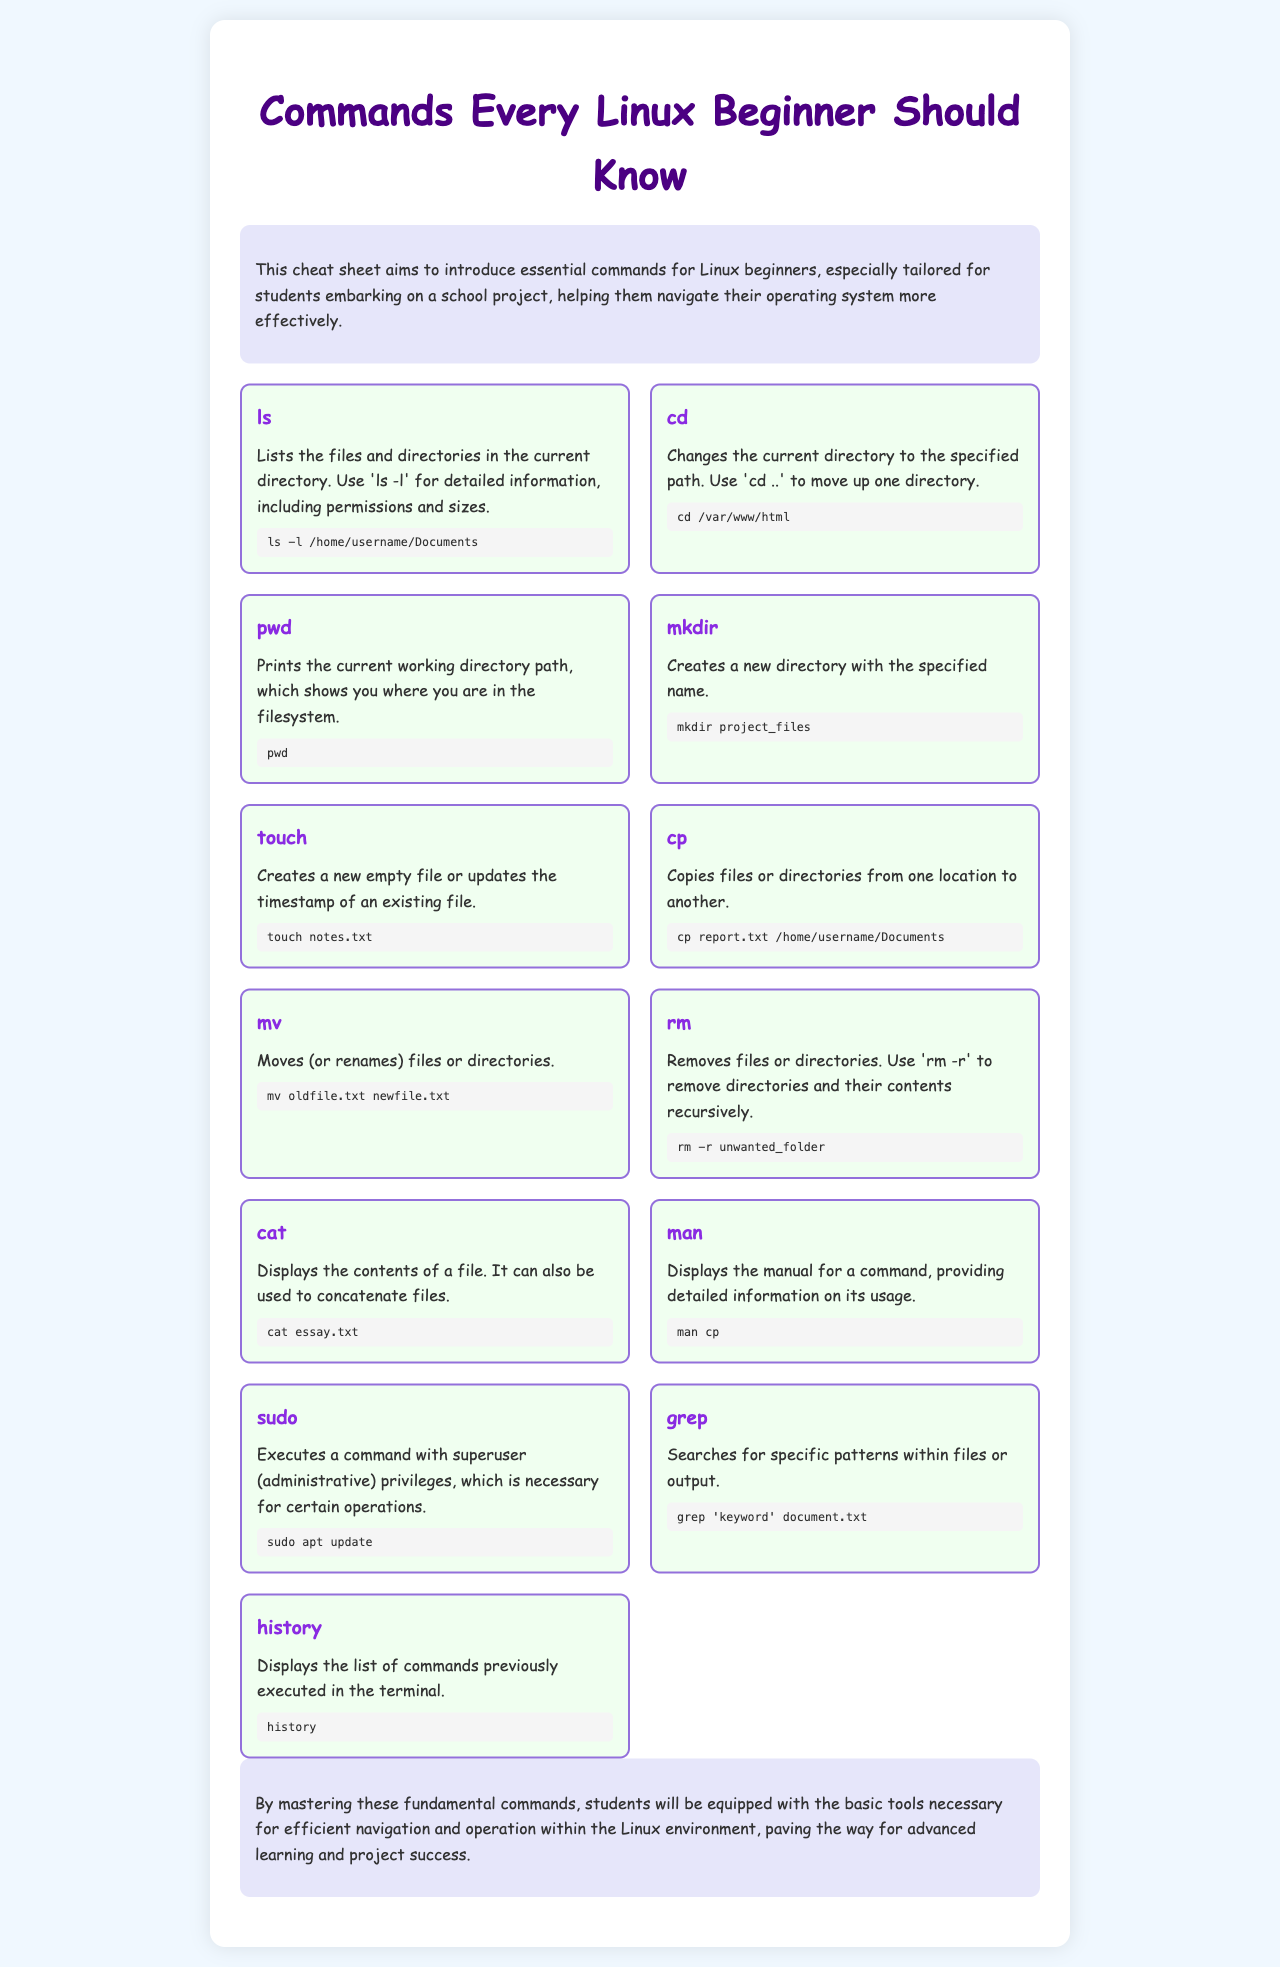what does the command 'ls' do? The command 'ls' lists the files and directories in the current directory.
Answer: lists files and directories what is the purpose of 'mkdir'? 'mkdir' is used to create a new directory with the specified name.
Answer: create a new directory how can you see the manual for the 'cp' command? You can see the manual for the 'cp' command by using the 'man cp' command.
Answer: man cp which command is used to execute commands with superuser privileges? The command used to execute commands with superuser privileges is 'sudo'.
Answer: sudo what will 'rm -r' do? 'rm -r' will remove directories and their contents recursively.
Answer: remove directories and contents how do you move one directory up in the terminal? You can move one directory up in the terminal by using the command 'cd ..'.
Answer: cd . what command displays the list of previously executed commands? The command that displays the list of previously executed commands is 'history'.
Answer: history what does 'touch' do in Linux? The command 'touch' creates a new empty file or updates the timestamp of an existing file.
Answer: creates or updates a file how many commands are listed in the cheat sheet? There are twelve commands listed in the cheat sheet.
Answer: twelve 